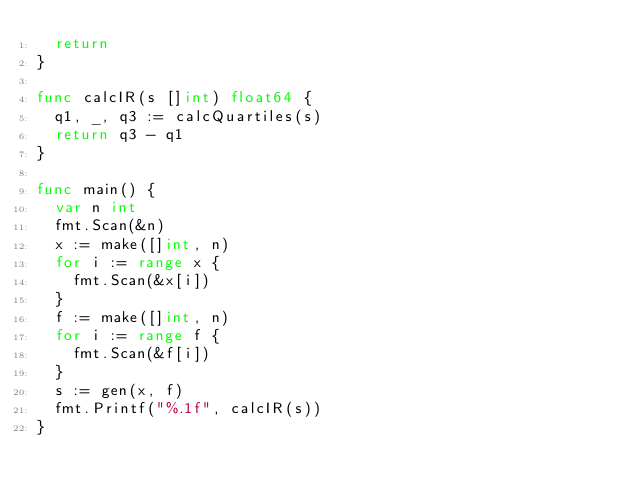<code> <loc_0><loc_0><loc_500><loc_500><_Go_>	return
}

func calcIR(s []int) float64 {
	q1, _, q3 := calcQuartiles(s)
	return q3 - q1
}

func main() {
	var n int
	fmt.Scan(&n)
	x := make([]int, n)
	for i := range x {
		fmt.Scan(&x[i])
	}
	f := make([]int, n)
	for i := range f {
		fmt.Scan(&f[i])
	}
	s := gen(x, f)
	fmt.Printf("%.1f", calcIR(s))
}
</code> 